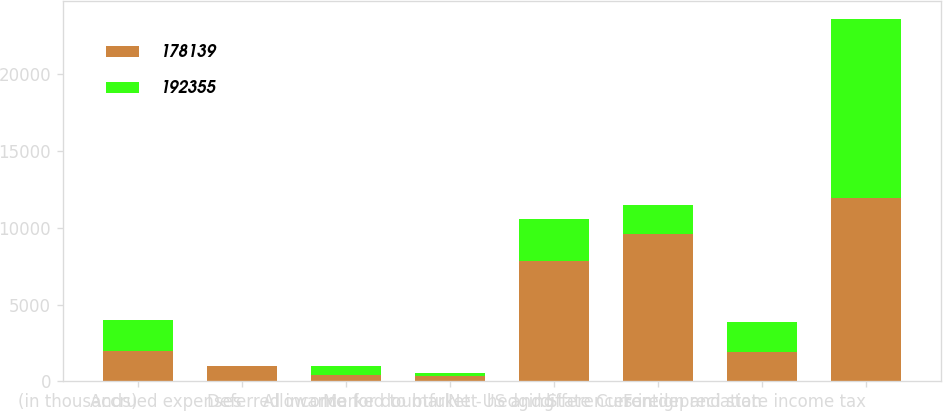Convert chart. <chart><loc_0><loc_0><loc_500><loc_500><stacked_bar_chart><ecel><fcel>(in thousands)<fcel>Accrued expenses<fcel>Deferred income<fcel>Allowance for doubtful<fcel>Marked to market - hedging<fcel>Net US and State Current<fcel>differences in depreciation<fcel>Foreign and state income tax<nl><fcel>178139<fcel>2002<fcel>980<fcel>387<fcel>353<fcel>7864<fcel>9584<fcel>1940.5<fcel>11940<nl><fcel>192355<fcel>2001<fcel>15<fcel>626<fcel>226<fcel>2730<fcel>1880<fcel>1940.5<fcel>11627<nl></chart> 